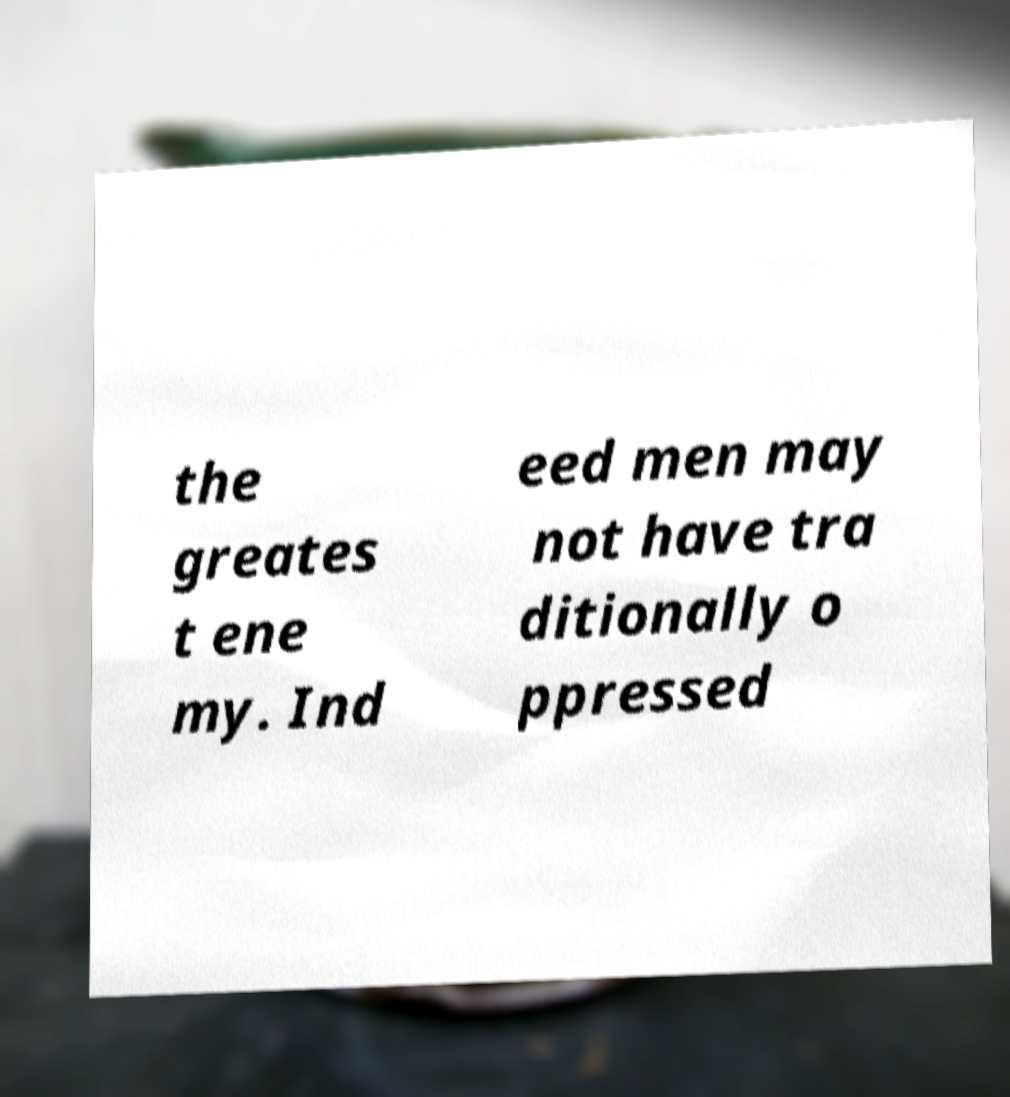There's text embedded in this image that I need extracted. Can you transcribe it verbatim? the greates t ene my. Ind eed men may not have tra ditionally o ppressed 